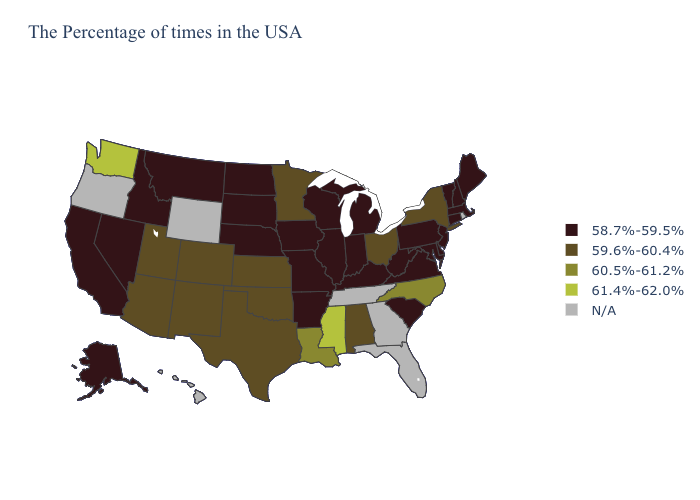What is the value of New Jersey?
Keep it brief. 58.7%-59.5%. What is the lowest value in the USA?
Answer briefly. 58.7%-59.5%. Does Ohio have the lowest value in the MidWest?
Be succinct. No. What is the highest value in the West ?
Be succinct. 61.4%-62.0%. Name the states that have a value in the range N/A?
Quick response, please. Rhode Island, Florida, Georgia, Tennessee, Wyoming, Oregon, Hawaii. What is the lowest value in the USA?
Quick response, please. 58.7%-59.5%. What is the value of Oregon?
Write a very short answer. N/A. Which states have the lowest value in the MidWest?
Short answer required. Michigan, Indiana, Wisconsin, Illinois, Missouri, Iowa, Nebraska, South Dakota, North Dakota. Name the states that have a value in the range 59.6%-60.4%?
Write a very short answer. New York, Ohio, Alabama, Minnesota, Kansas, Oklahoma, Texas, Colorado, New Mexico, Utah, Arizona. What is the value of Rhode Island?
Quick response, please. N/A. Which states hav the highest value in the Northeast?
Concise answer only. New York. Among the states that border Colorado , which have the lowest value?
Keep it brief. Nebraska. How many symbols are there in the legend?
Keep it brief. 5. What is the value of Utah?
Answer briefly. 59.6%-60.4%. 